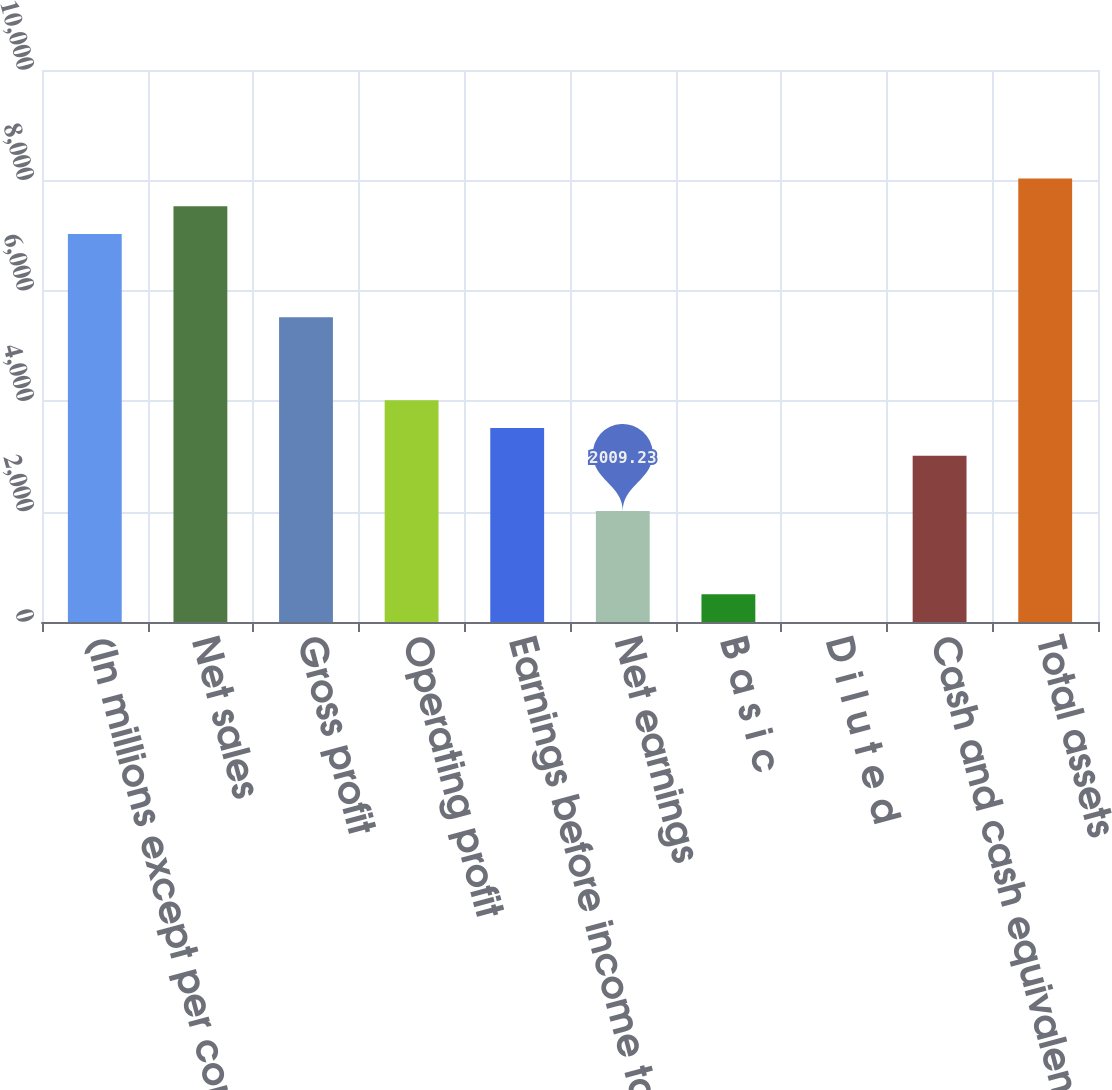Convert chart to OTSL. <chart><loc_0><loc_0><loc_500><loc_500><bar_chart><fcel>(In millions except per common<fcel>Net sales<fcel>Gross profit<fcel>Operating profit<fcel>Earnings before income tax<fcel>Net earnings<fcel>B a s i c<fcel>D i l u t e d<fcel>Cash and cash equivalents<fcel>Total assets<nl><fcel>7028.63<fcel>7530.57<fcel>5522.81<fcel>4016.99<fcel>3515.05<fcel>2009.23<fcel>503.41<fcel>1.47<fcel>3013.11<fcel>8032.51<nl></chart> 